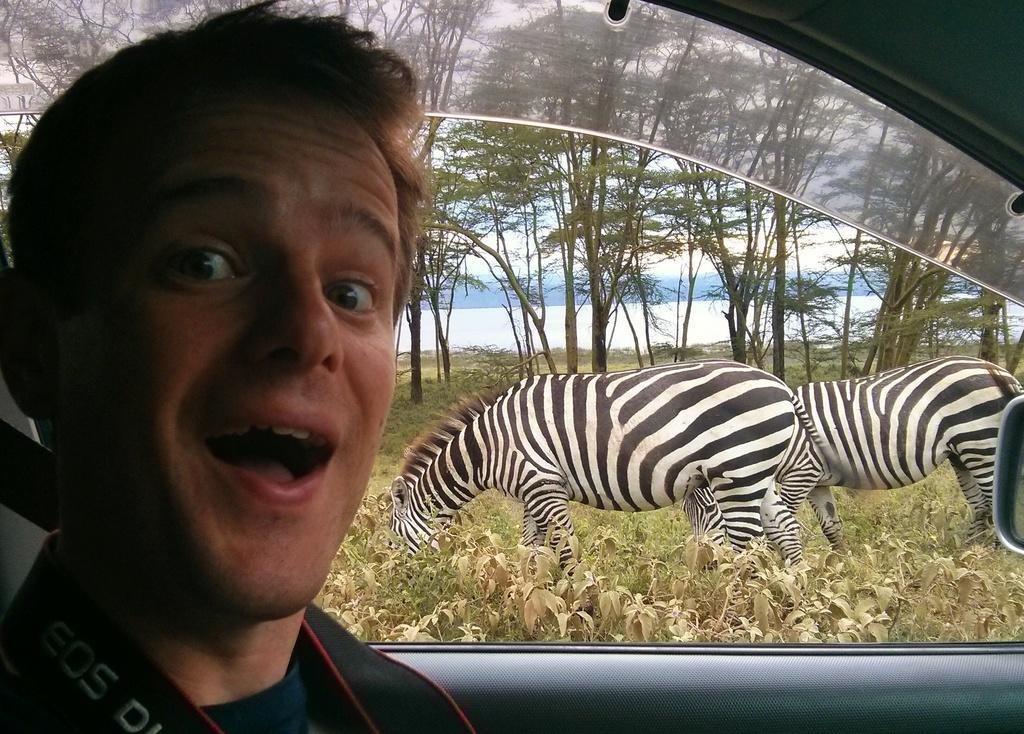How would you summarize this image in a sentence or two? In the image there is a person sitting inside a car and behind there are two zebras grazing grass with trees in the background followed by a lake. 